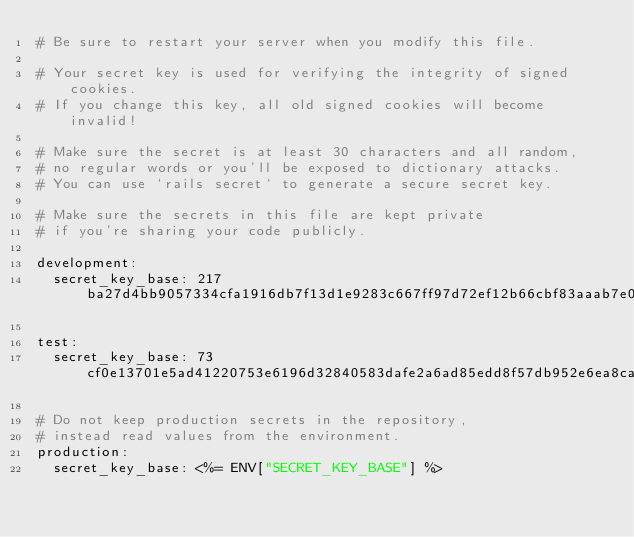Convert code to text. <code><loc_0><loc_0><loc_500><loc_500><_YAML_># Be sure to restart your server when you modify this file.

# Your secret key is used for verifying the integrity of signed cookies.
# If you change this key, all old signed cookies will become invalid!

# Make sure the secret is at least 30 characters and all random,
# no regular words or you'll be exposed to dictionary attacks.
# You can use `rails secret` to generate a secure secret key.

# Make sure the secrets in this file are kept private
# if you're sharing your code publicly.

development:
  secret_key_base: 217ba27d4bb9057334cfa1916db7f13d1e9283c667ff97d72ef12b66cbf83aaab7e0e88e841766ccaf231d5741e6ea92c8a829f2b1b4c69aae166ae351876af0

test:
  secret_key_base: 73cf0e13701e5ad41220753e6196d32840583dafe2a6ad85edd8f57db952e6ea8ca52b607dcfc2d8ce8d3d3aa8af98195276449d0f9e02b656a65351a699904e

# Do not keep production secrets in the repository,
# instead read values from the environment.
production:
  secret_key_base: <%= ENV["SECRET_KEY_BASE"] %>
</code> 